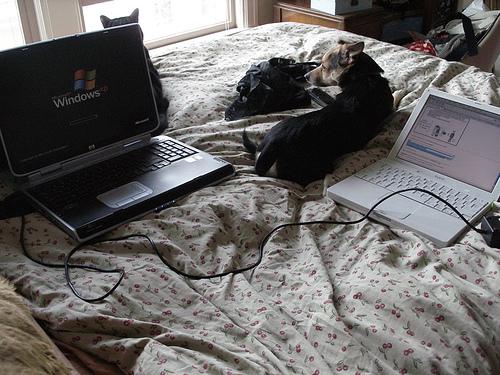How many computers are on the bed?
Be succinct. 2. How many animals are on the bed?
Answer briefly. 2. What operating system is on the left?
Quick response, please. Windows. 